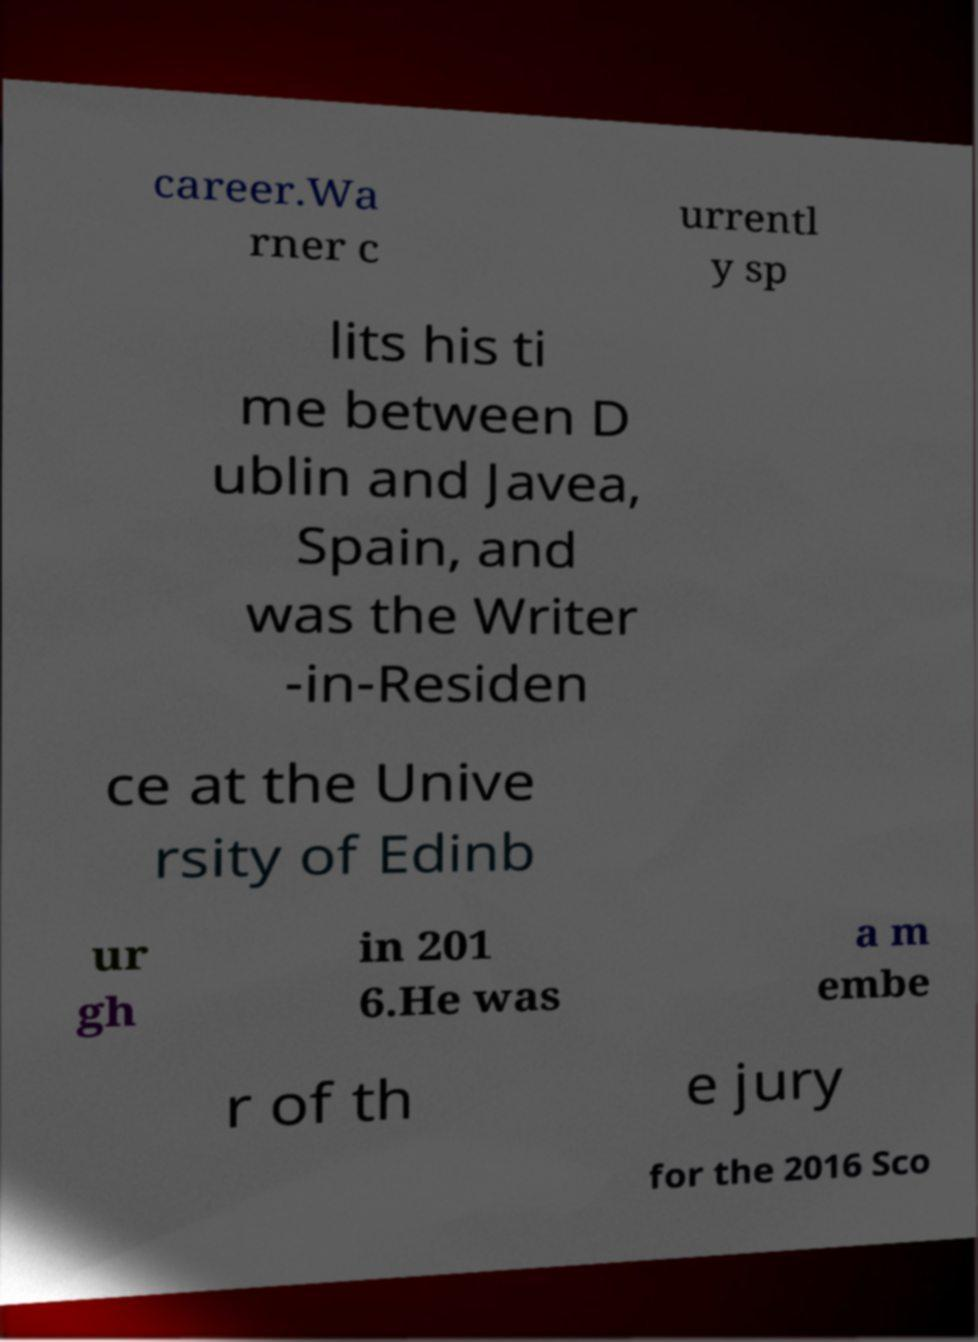For documentation purposes, I need the text within this image transcribed. Could you provide that? career.Wa rner c urrentl y sp lits his ti me between D ublin and Javea, Spain, and was the Writer -in-Residen ce at the Unive rsity of Edinb ur gh in 201 6.He was a m embe r of th e jury for the 2016 Sco 